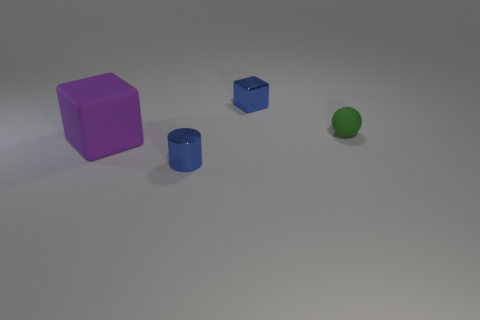Add 1 metallic cylinders. How many objects exist? 5 Subtract 1 cylinders. How many cylinders are left? 0 Subtract all blue cubes. How many cubes are left? 1 Add 2 cyan cubes. How many cyan cubes exist? 2 Subtract 0 green blocks. How many objects are left? 4 Subtract all balls. How many objects are left? 3 Subtract all cyan blocks. Subtract all yellow cylinders. How many blocks are left? 2 Subtract all purple matte cubes. Subtract all gray objects. How many objects are left? 3 Add 2 small rubber balls. How many small rubber balls are left? 3 